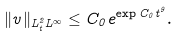Convert formula to latex. <formula><loc_0><loc_0><loc_500><loc_500>\| v \| _ { L ^ { 2 } _ { t } L ^ { \infty } } \leq C _ { 0 } e ^ { \exp { C _ { 0 } t ^ { 9 } } } .</formula> 